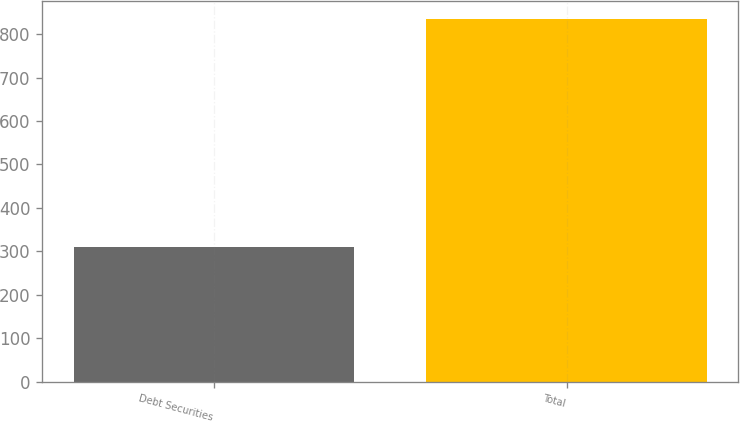<chart> <loc_0><loc_0><loc_500><loc_500><bar_chart><fcel>Debt Securities<fcel>Total<nl><fcel>309.3<fcel>834.7<nl></chart> 